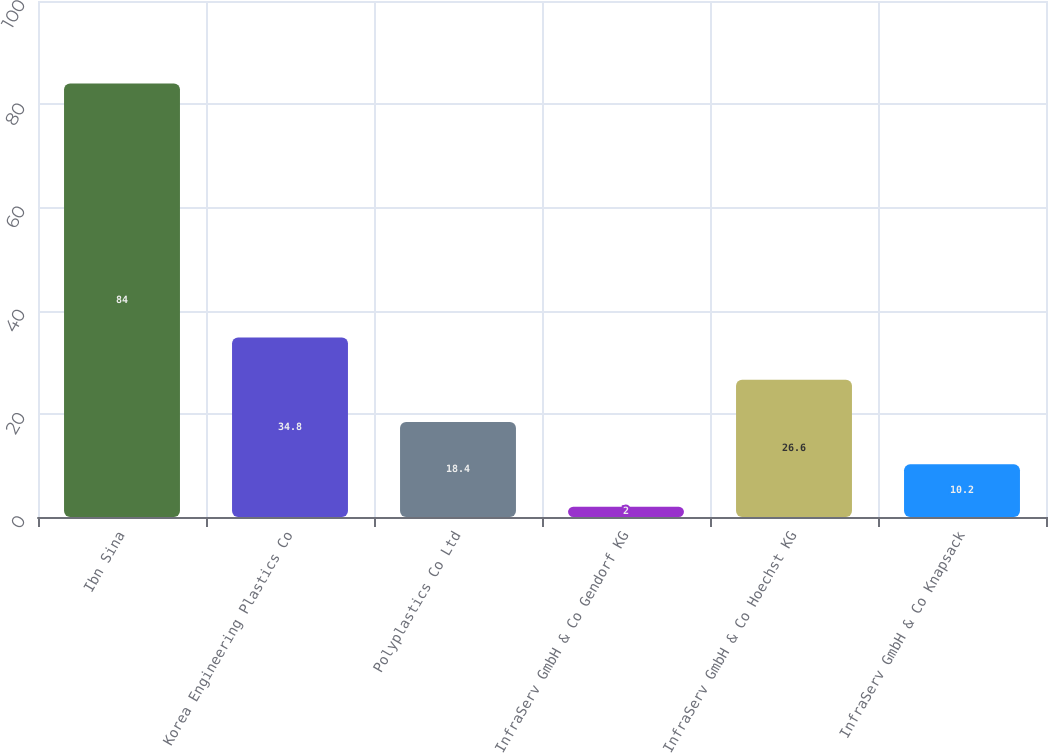Convert chart. <chart><loc_0><loc_0><loc_500><loc_500><bar_chart><fcel>Ibn Sina<fcel>Korea Engineering Plastics Co<fcel>Polyplastics Co Ltd<fcel>InfraServ GmbH & Co Gendorf KG<fcel>InfraServ GmbH & Co Hoechst KG<fcel>InfraServ GmbH & Co Knapsack<nl><fcel>84<fcel>34.8<fcel>18.4<fcel>2<fcel>26.6<fcel>10.2<nl></chart> 